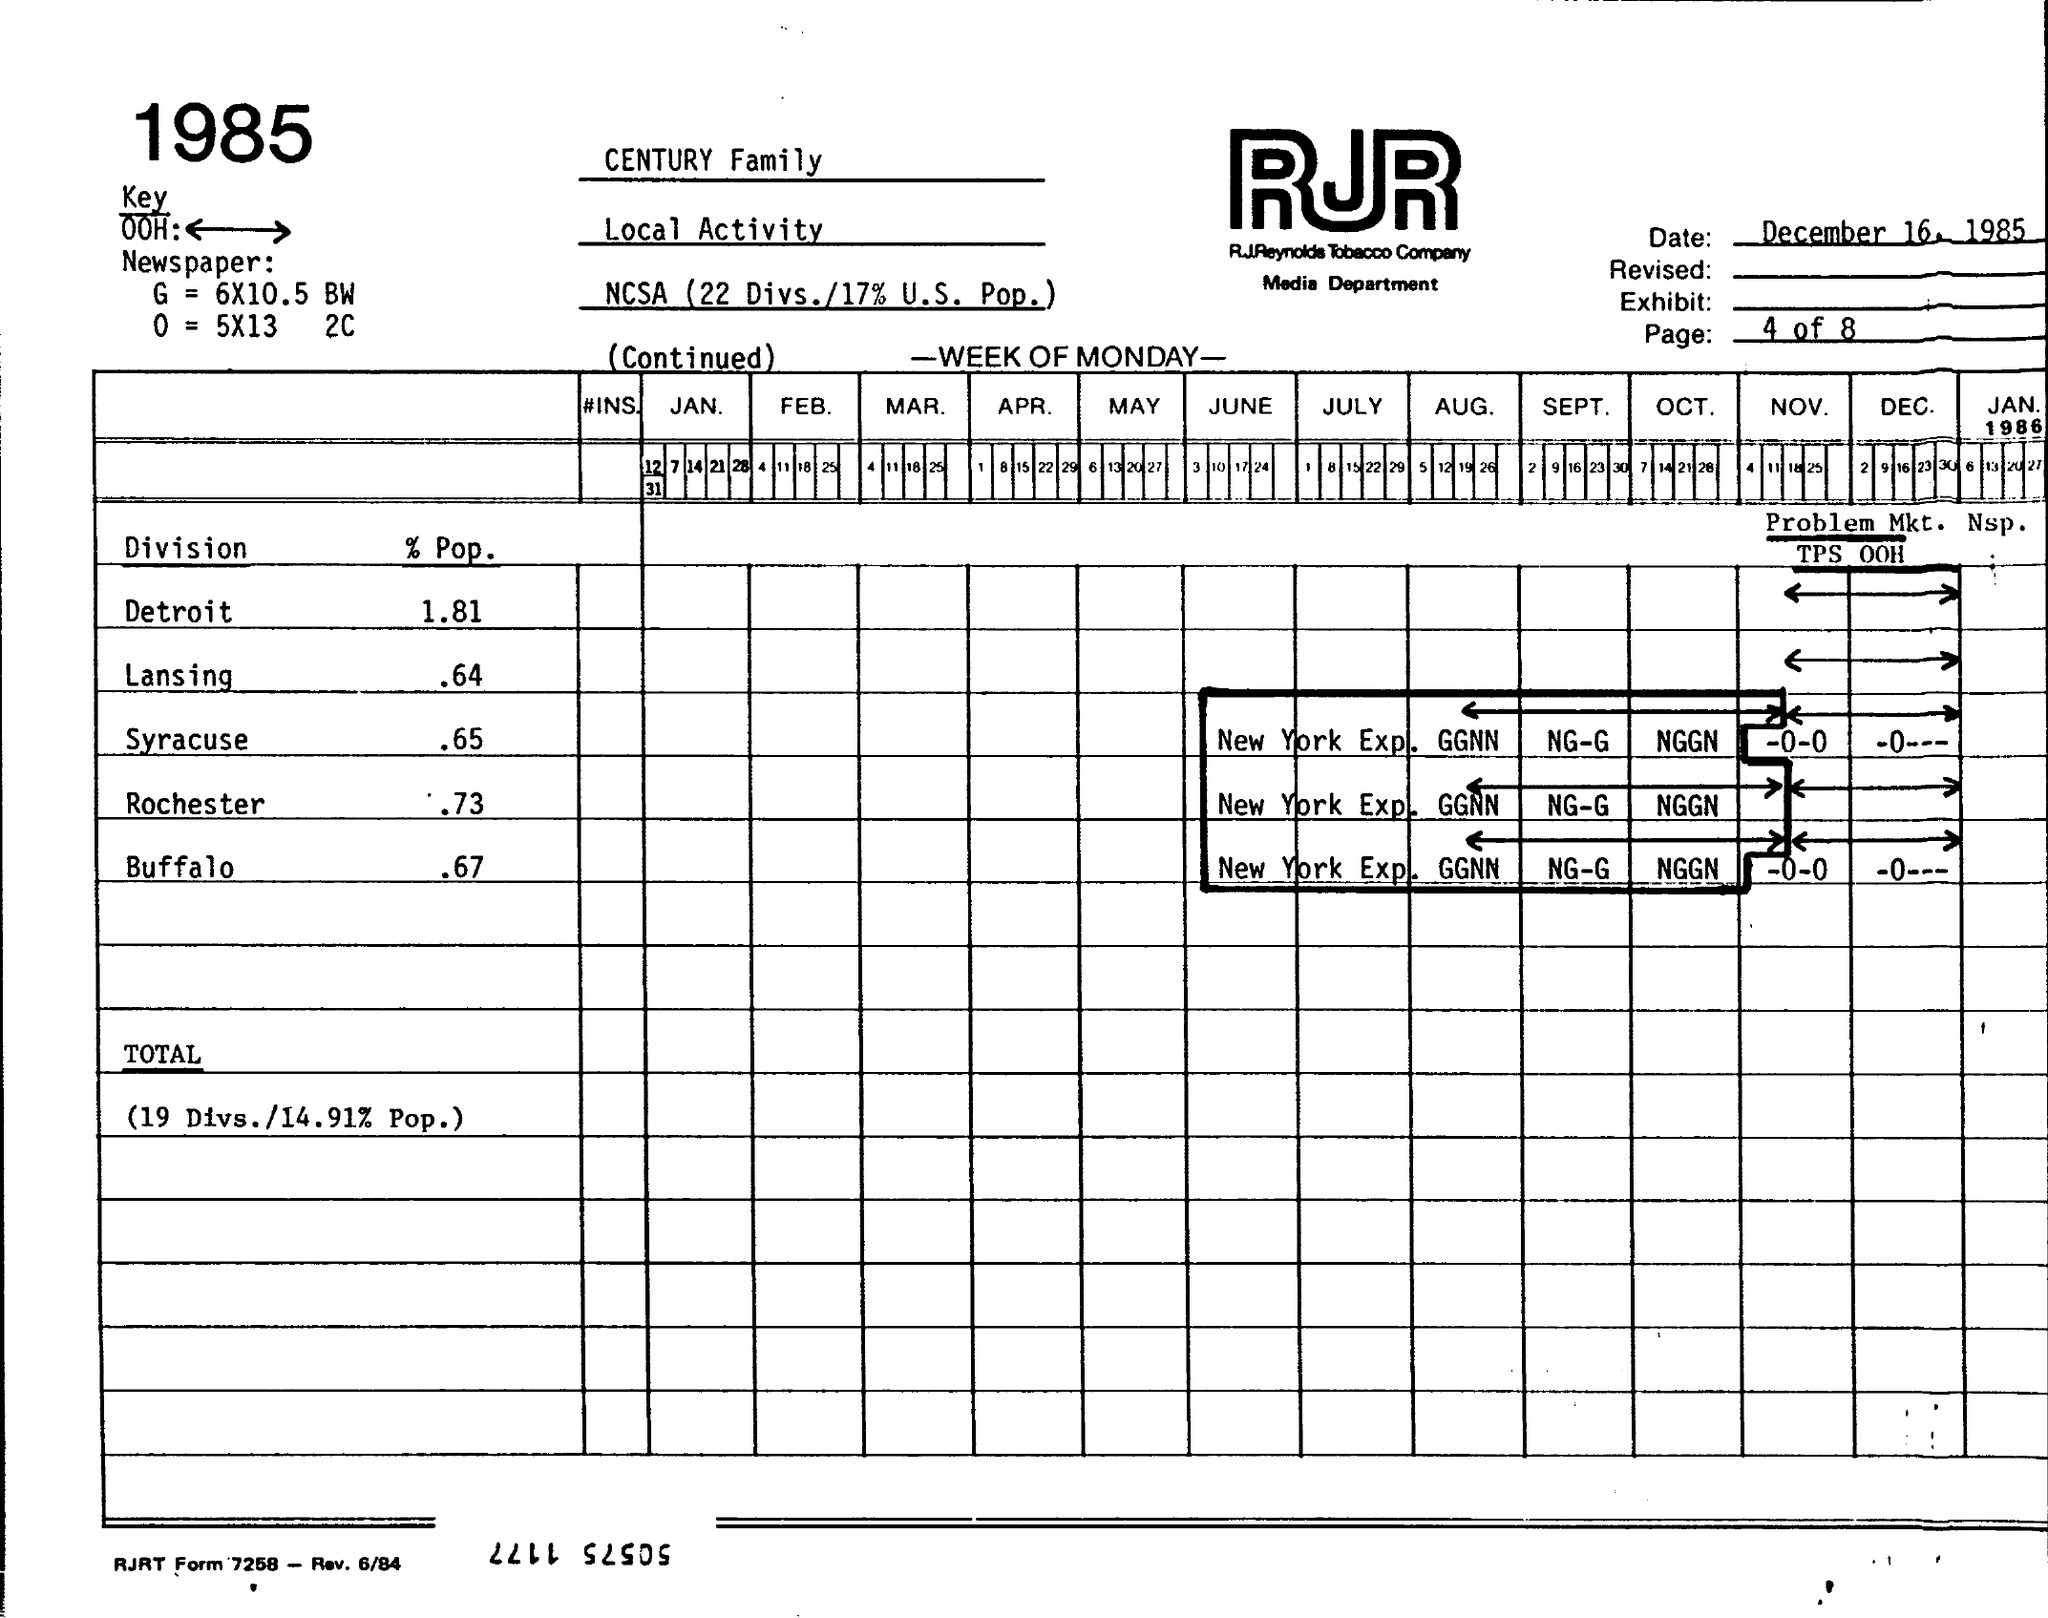What is the Date?
Ensure brevity in your answer.  December 16, 1985. What is the % Pop for Detroit?
Your response must be concise. 1.81. What is the % Pop for Lansing?
Offer a terse response. .64. What is the % Pop for Syracuse?
Ensure brevity in your answer.  .65. What is the % Pop for Rochester?
Provide a succinct answer. .73. What is the % Pop for Buffalo?
Your answer should be compact. .67. 